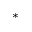Convert formula to latex. <formula><loc_0><loc_0><loc_500><loc_500>^ { \ast }</formula> 